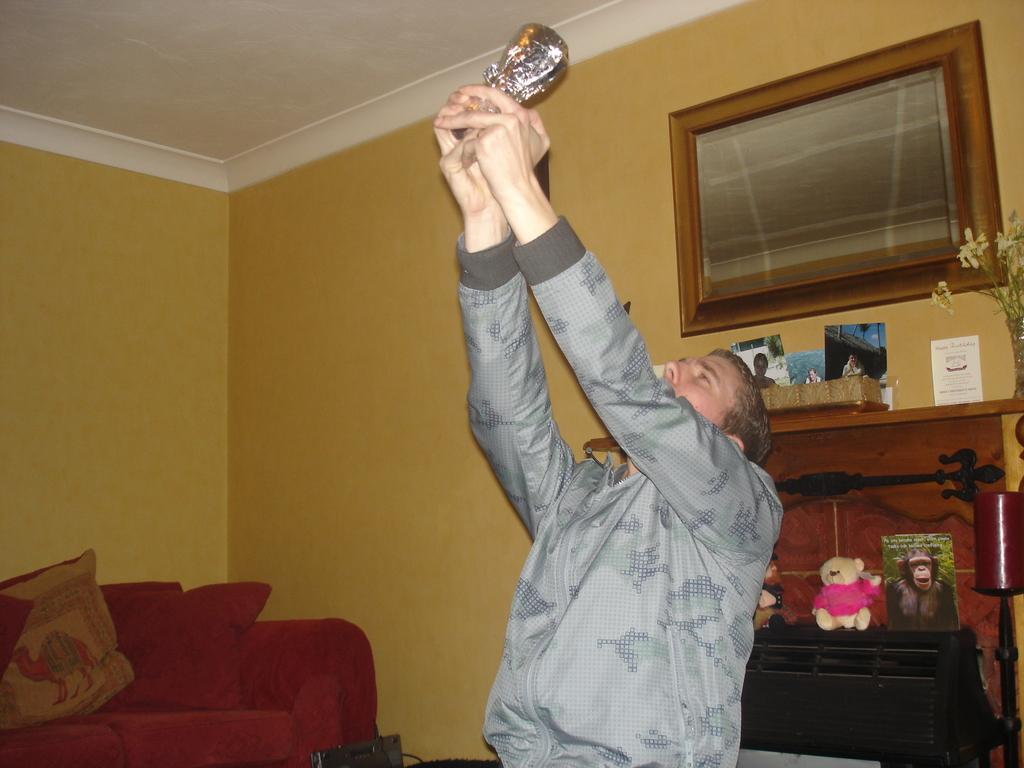Please provide a concise description of this image. In this picture there is a man who is wearing jacket and holding some object. On the left I can see the red couch and pillows near to the wall. On the right I can see the fireplace and lamp. In the top right there is a painting. 